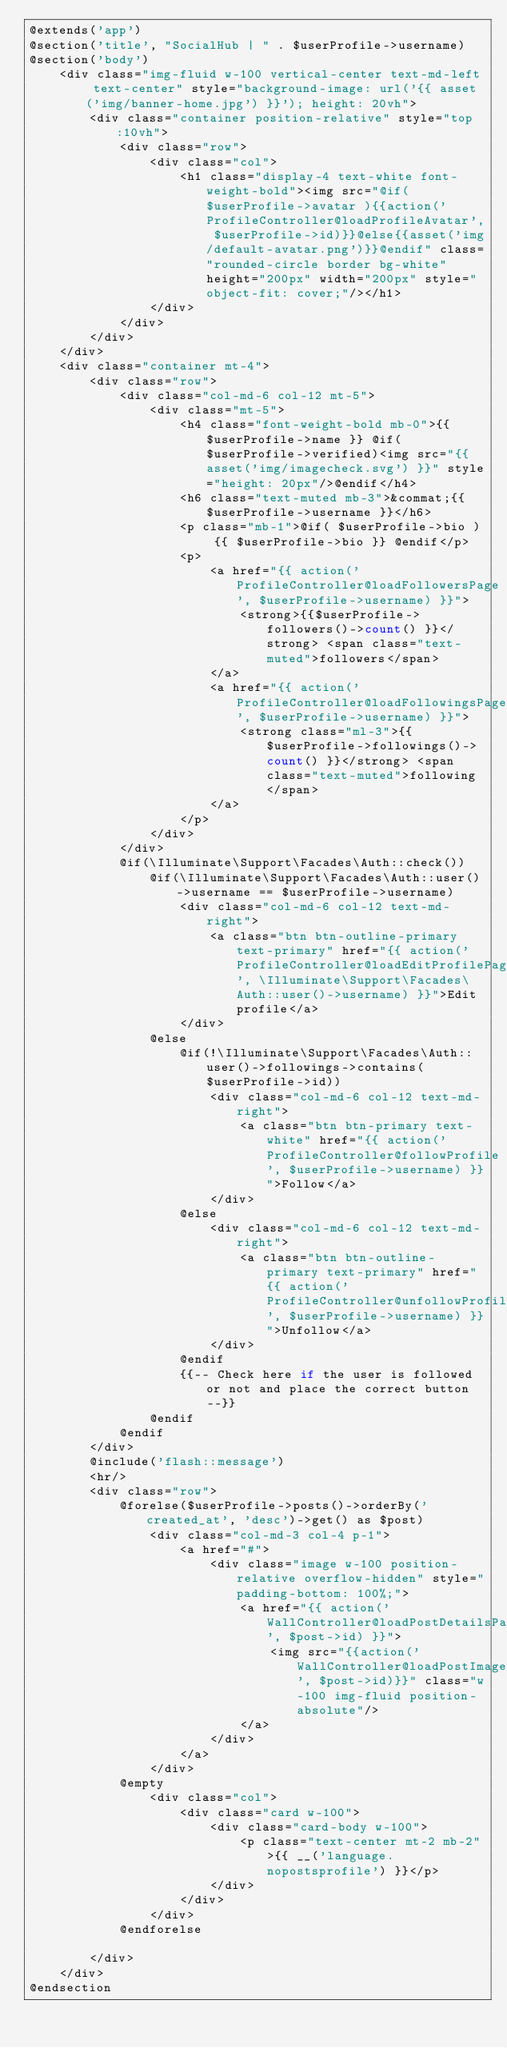Convert code to text. <code><loc_0><loc_0><loc_500><loc_500><_PHP_>@extends('app')
@section('title', "SocialHub | " . $userProfile->username)
@section('body')
    <div class="img-fluid w-100 vertical-center text-md-left text-center" style="background-image: url('{{ asset('img/banner-home.jpg') }}'); height: 20vh">
        <div class="container position-relative" style="top:10vh">
            <div class="row">
                <div class="col">
                    <h1 class="display-4 text-white font-weight-bold"><img src="@if( $userProfile->avatar ){{action('ProfileController@loadProfileAvatar', $userProfile->id)}}@else{{asset('img/default-avatar.png')}}@endif" class="rounded-circle border bg-white" height="200px" width="200px" style="object-fit: cover;"/></h1>
                </div>
            </div>
        </div>
    </div>
    <div class="container mt-4">
        <div class="row">
            <div class="col-md-6 col-12 mt-5">
                <div class="mt-5">
                    <h4 class="font-weight-bold mb-0">{{ $userProfile->name }} @if($userProfile->verified)<img src="{{ asset('img/imagecheck.svg') }}" style="height: 20px"/>@endif</h4>
                    <h6 class="text-muted mb-3">&commat;{{ $userProfile->username }}</h6>
                    <p class="mb-1">@if( $userProfile->bio ) {{ $userProfile->bio }} @endif</p>
                    <p>
                        <a href="{{ action('ProfileController@loadFollowersPage', $userProfile->username) }}">
                            <strong>{{$userProfile->followers()->count() }}</strong> <span class="text-muted">followers</span>
                        </a>
                        <a href="{{ action('ProfileController@loadFollowingsPage', $userProfile->username) }}">
                            <strong class="ml-3">{{ $userProfile->followings()->count() }}</strong> <span class="text-muted">following</span>
                        </a>
                    </p>
                </div>
            </div>
            @if(\Illuminate\Support\Facades\Auth::check())
                @if(\Illuminate\Support\Facades\Auth::user()->username == $userProfile->username)
                    <div class="col-md-6 col-12 text-md-right">
                        <a class="btn btn-outline-primary text-primary" href="{{ action('ProfileController@loadEditProfilePage', \Illuminate\Support\Facades\Auth::user()->username) }}">Edit profile</a>
                    </div>
                @else
                    @if(!\Illuminate\Support\Facades\Auth::user()->followings->contains($userProfile->id))
                        <div class="col-md-6 col-12 text-md-right">
                            <a class="btn btn-primary text-white" href="{{ action('ProfileController@followProfile', $userProfile->username) }}">Follow</a>
                        </div>
                    @else
                        <div class="col-md-6 col-12 text-md-right">
                            <a class="btn btn-outline-primary text-primary" href="{{ action('ProfileController@unfollowProfile', $userProfile->username) }}">Unfollow</a>
                        </div>
                    @endif
                    {{-- Check here if the user is followed or not and place the correct button --}}
                @endif
            @endif
        </div>
        @include('flash::message')
        <hr/>
        <div class="row">
            @forelse($userProfile->posts()->orderBy('created_at', 'desc')->get() as $post)
                <div class="col-md-3 col-4 p-1">
                    <a href="#">
                        <div class="image w-100 position-relative overflow-hidden" style="padding-bottom: 100%;">
                            <a href="{{ action('WallController@loadPostDetailsPage', $post->id) }}">
                                <img src="{{action('WallController@loadPostImage', $post->id)}}" class="w-100 img-fluid position-absolute"/>
                            </a>
                        </div>
                    </a>
                </div>
            @empty
                <div class="col">
                    <div class="card w-100">
                        <div class="card-body w-100">
                            <p class="text-center mt-2 mb-2">{{ __('language.nopostsprofile') }}</p>
                        </div>
                    </div>
                </div>
            @endforelse

        </div>
    </div>
@endsection
</code> 